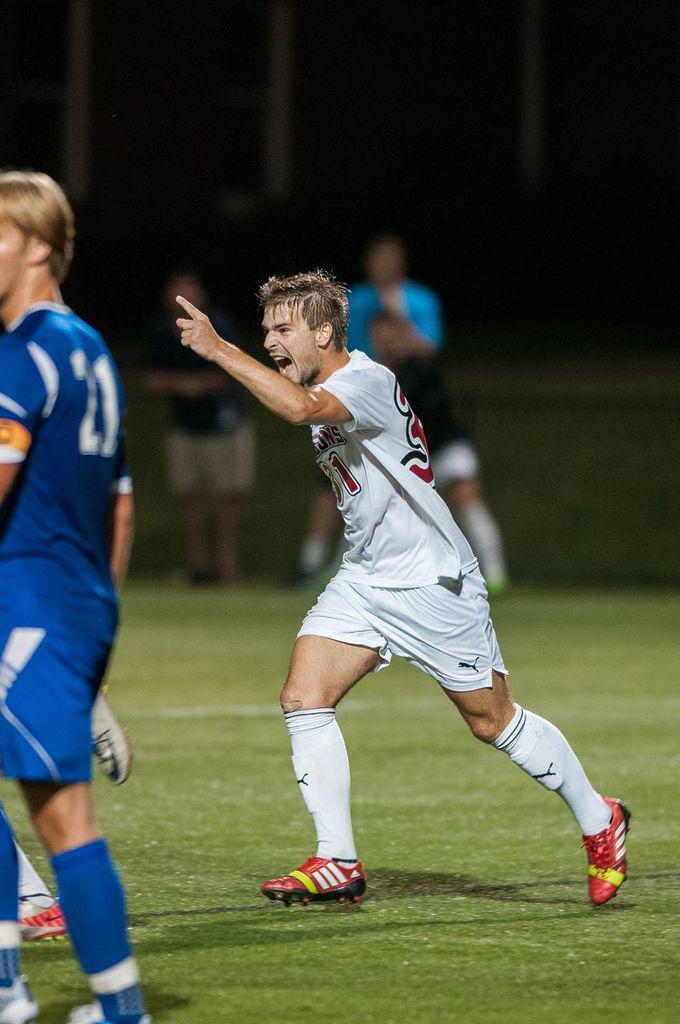Could you give a brief overview of what you see in this image? In this image, I can see the man walking. On the left side of the image, I think there are two people standing. This is the grass. In the background, I think there are three people standing. 